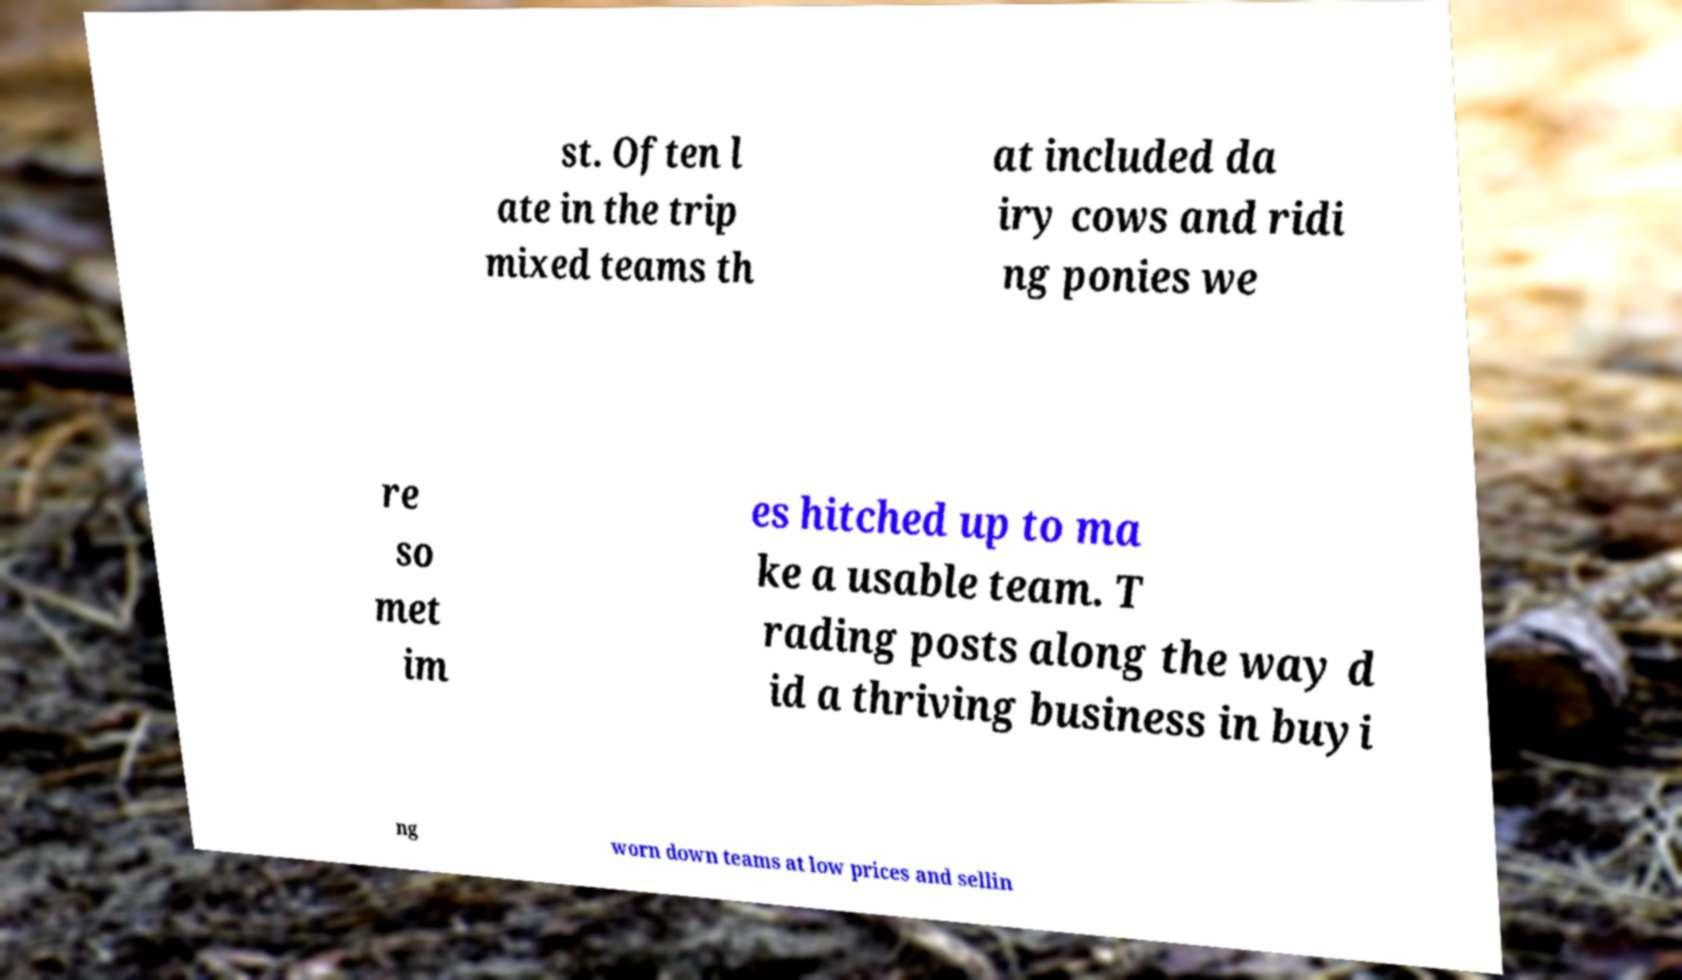Please read and relay the text visible in this image. What does it say? st. Often l ate in the trip mixed teams th at included da iry cows and ridi ng ponies we re so met im es hitched up to ma ke a usable team. T rading posts along the way d id a thriving business in buyi ng worn down teams at low prices and sellin 